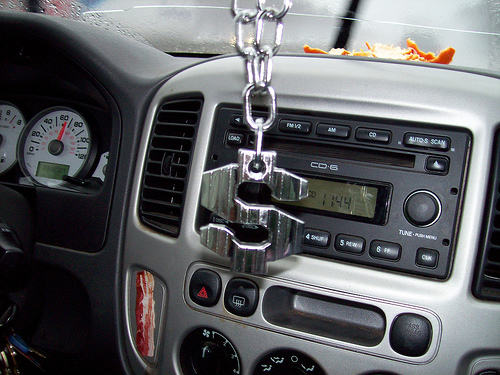<image>
Is there a necklace above the dial? Yes. The necklace is positioned above the dial in the vertical space, higher up in the scene. 